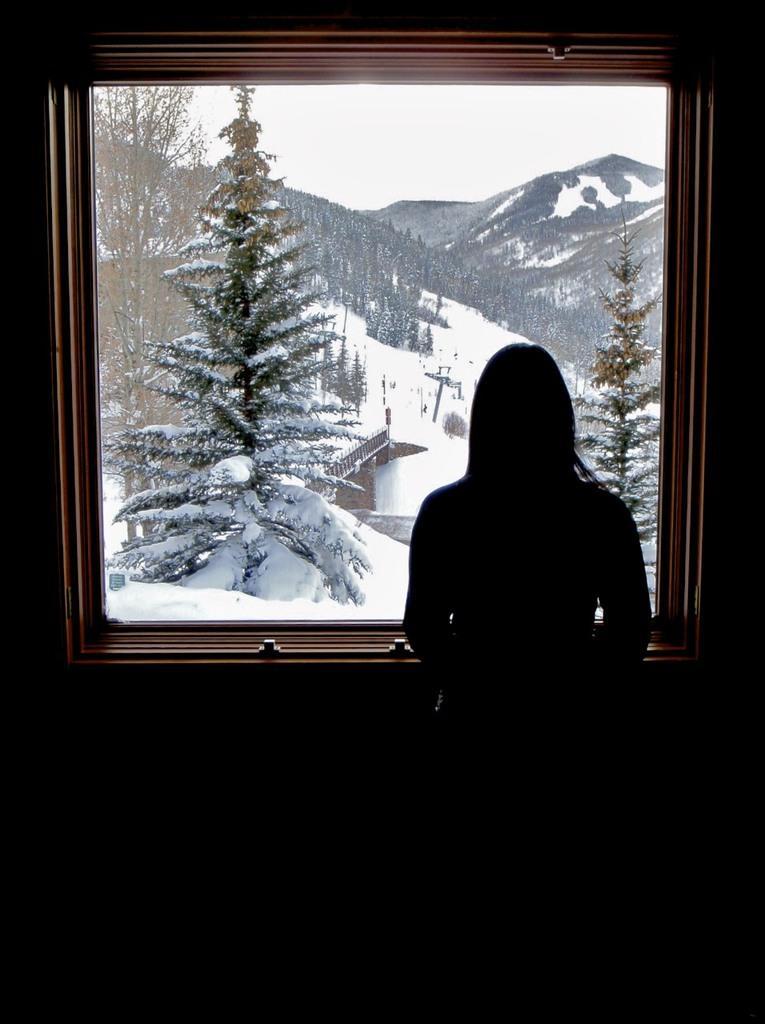Can you describe this image briefly? There is a woman standing near to the window. Through the window we can see trees, hills and sky. And is covered with snow. 